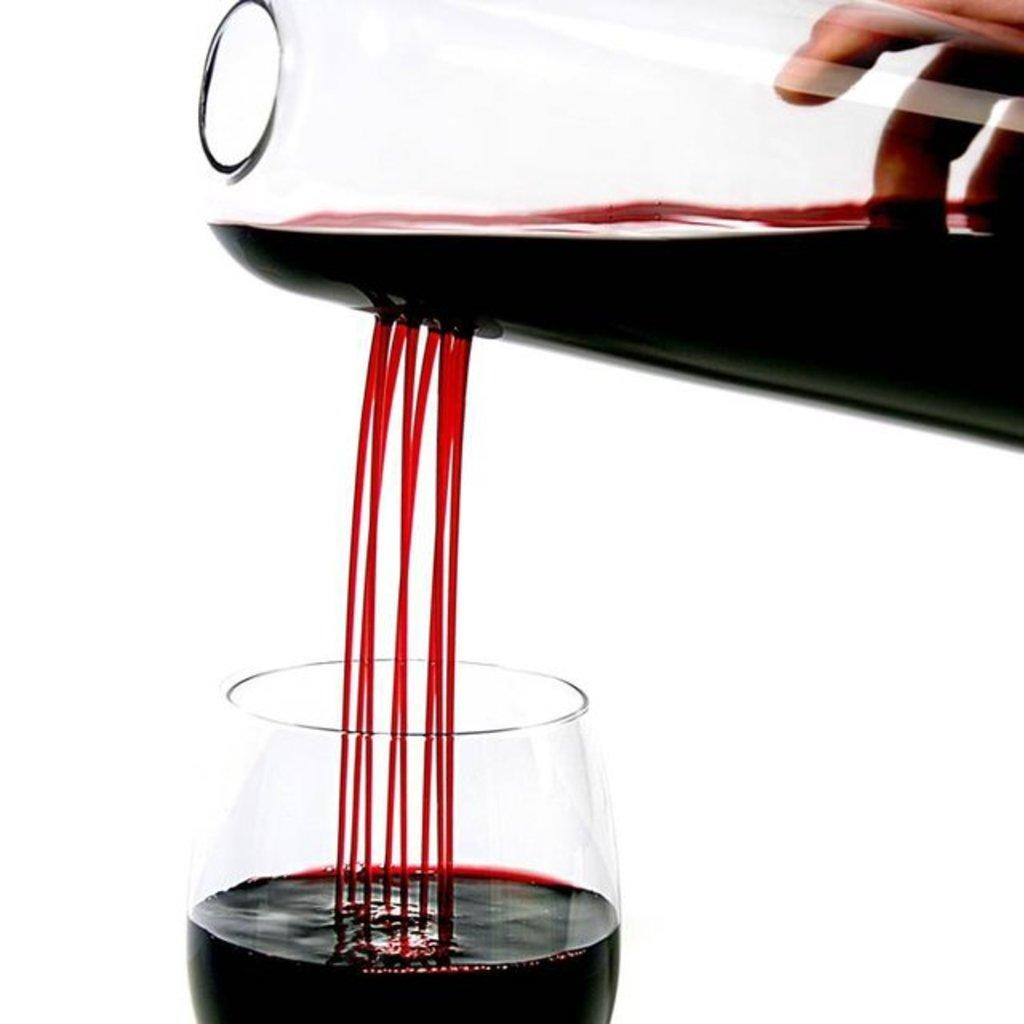What is being poured in the image? The person's hand is pouring red wine in the image. How is the red wine being poured? The red wine is being poured through a jar. What is below the jar? There is a glass below the jar. What type of fuel is being used to power the channel in the image? There is no fuel or channel present in the image; it features a person's hand pouring red wine through a jar into a glass. 